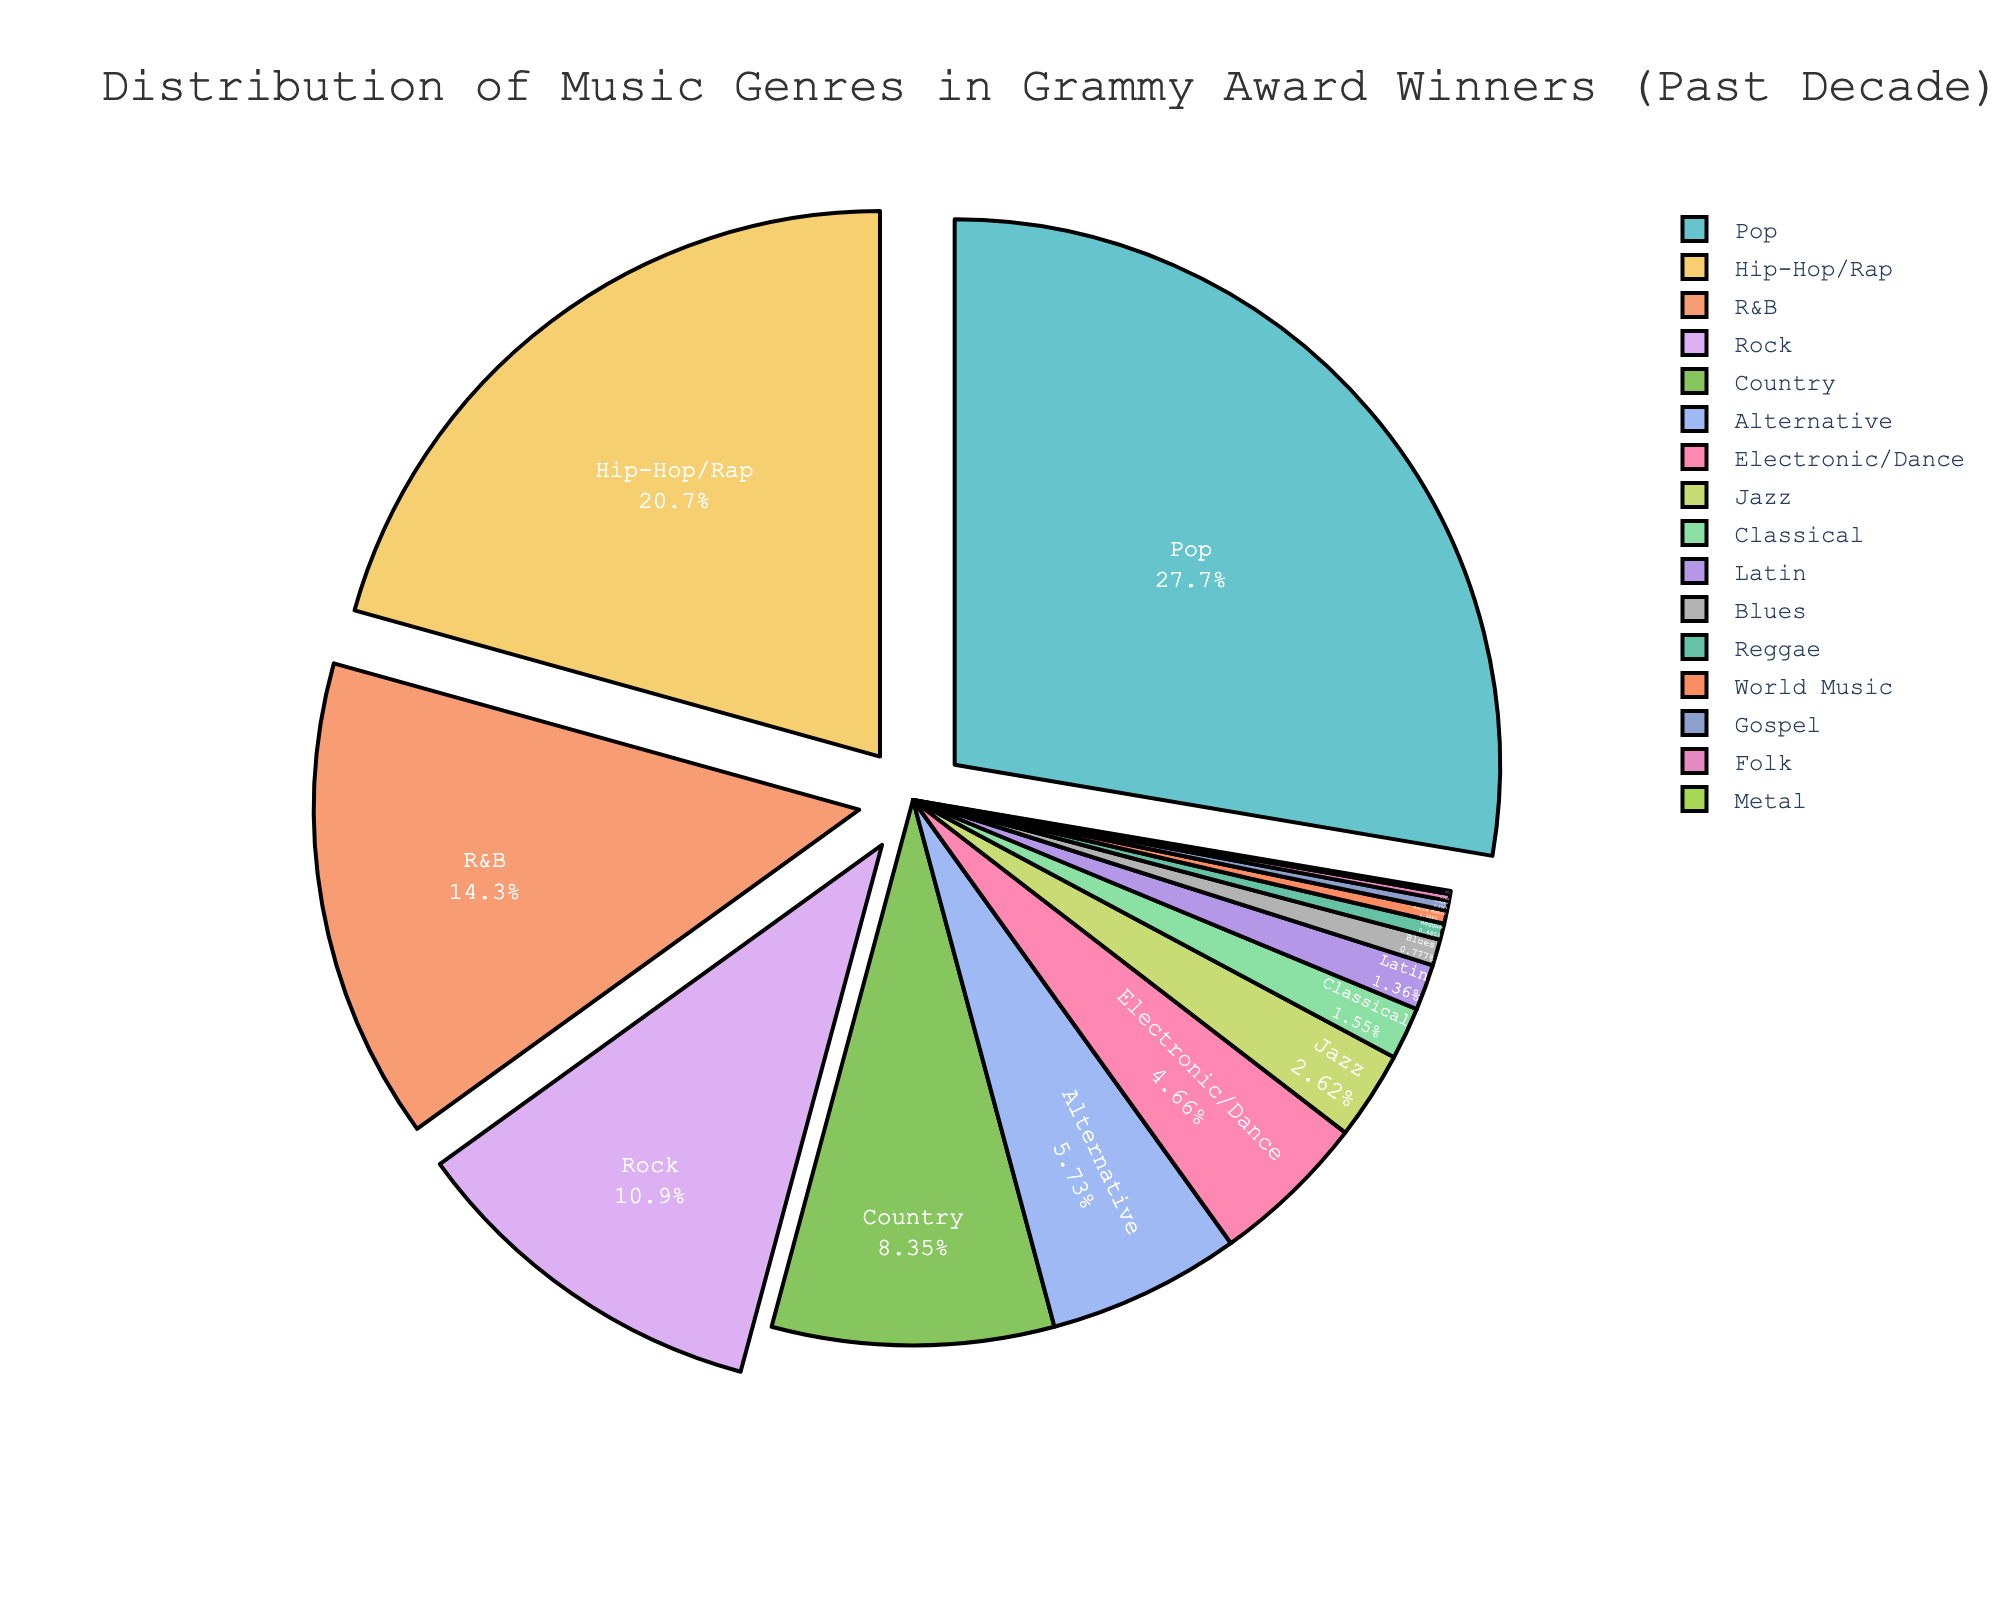Which music genre has the highest percentage of Grammy Award winners over the past decade? The chart shows the percentage distribution of different music genres in Grammy Award winners. Pop has the largest segment in the pie chart.
Answer: Pop What is the combined percentage of Grammy Award winners for R&B and Rock genres? The pie chart shows R&B with 14.7% and Rock with 11.2%. Adding these percentages gives 14.7 + 11.2 = 25.9%.
Answer: 25.9% Which genres have a percentage of Grammy Award winners greater than 20%? The pie chart shows Pop at 28.5% and Hip-Hop/Rap at 21.3%. Both these genres are above 20%.
Answer: Pop, Hip-Hop/Rap How much more percentage does Pop have compared to Country in Grammy Award winners? Pop has 28.5% and Country has 8.6%. Subtracting these percentages gives 28.5 - 8.6 = 19.9%.
Answer: 19.9% If you combine the percentages of Classical, Latin, Blues, Reggae, World Music, Gospel, Folk, and Metal, does it surpass the percentage of Electronic/Dance? Summing the percentages: 1.6 + 1.4 + 0.8 + 0.5 + 0.4 + 0.3 + 0.2 + 0.1 = 5.3%, which is greater than Electronic/Dance at 4.8%.
Answer: Yes Which genre has the smallest percentage of Grammy Award winners and what is its value? The pie chart shows Metal with the smallest segment at 0.1%.
Answer: Metal, 0.1% How many genres have a percentage of Grammy Award winners less than 1%? The pie chart shows Latin (1.4%), Blues (0.8%), Reggae (0.5%), World Music (0.4%), Gospel (0.3%), Folk (0.2%), and Metal (0.1%) as having less than 1%.
Answer: 6 